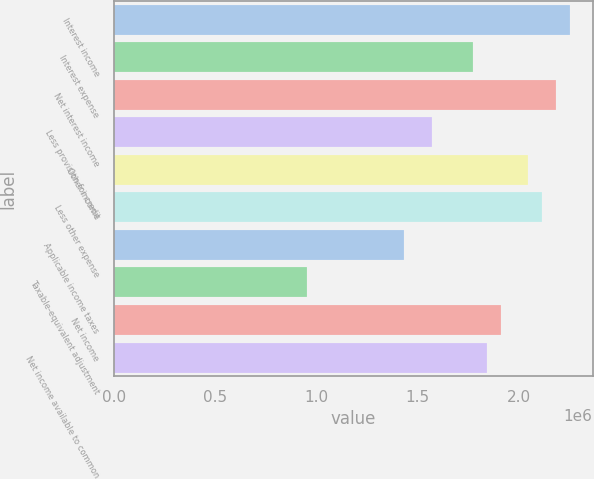Convert chart to OTSL. <chart><loc_0><loc_0><loc_500><loc_500><bar_chart><fcel>Interest income<fcel>Interest expense<fcel>Net interest income<fcel>Less provision for credit<fcel>Other income<fcel>Less other expense<fcel>Applicable income taxes<fcel>Taxable-equivalent adjustment<fcel>Net income<fcel>Net income available to common<nl><fcel>2.25162e+06<fcel>1.774e+06<fcel>2.18339e+06<fcel>1.56931e+06<fcel>2.04693e+06<fcel>2.11516e+06<fcel>1.43285e+06<fcel>955232<fcel>1.91046e+06<fcel>1.84223e+06<nl></chart> 